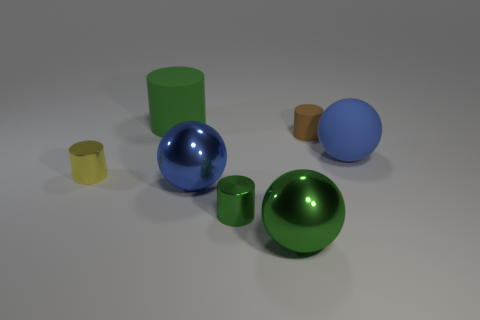There is a small cylinder that is in front of the yellow metallic cylinder; is it the same color as the big rubber cylinder?
Keep it short and to the point. Yes. There is a matte ball; is it the same color as the big shiny sphere left of the small green metal cylinder?
Your response must be concise. Yes. What number of other objects are the same material as the tiny yellow cylinder?
Provide a short and direct response. 3. There is a large green object that is the same material as the brown cylinder; what is its shape?
Your response must be concise. Cylinder. Is there any other thing that has the same color as the tiny matte object?
Your answer should be very brief. No. There is another metallic cylinder that is the same color as the large cylinder; what size is it?
Your answer should be compact. Small. Are there more green rubber cylinders that are behind the tiny rubber object than large yellow metal cylinders?
Provide a short and direct response. Yes. Do the small yellow object and the blue object in front of the small yellow metallic cylinder have the same shape?
Provide a succinct answer. No. How many green metallic cylinders are the same size as the brown matte cylinder?
Make the answer very short. 1. There is a green cylinder that is in front of the green thing that is behind the big blue matte object; how many balls are behind it?
Provide a short and direct response. 2. 